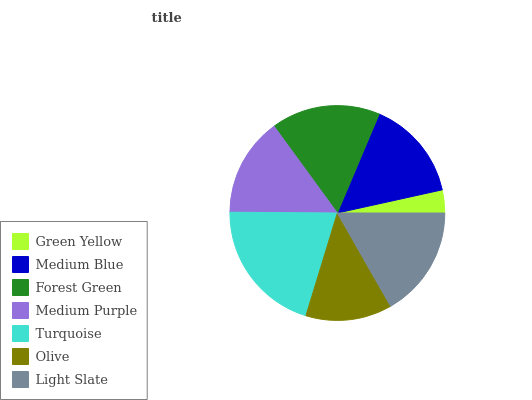Is Green Yellow the minimum?
Answer yes or no. Yes. Is Turquoise the maximum?
Answer yes or no. Yes. Is Medium Blue the minimum?
Answer yes or no. No. Is Medium Blue the maximum?
Answer yes or no. No. Is Medium Blue greater than Green Yellow?
Answer yes or no. Yes. Is Green Yellow less than Medium Blue?
Answer yes or no. Yes. Is Green Yellow greater than Medium Blue?
Answer yes or no. No. Is Medium Blue less than Green Yellow?
Answer yes or no. No. Is Medium Blue the high median?
Answer yes or no. Yes. Is Medium Blue the low median?
Answer yes or no. Yes. Is Light Slate the high median?
Answer yes or no. No. Is Olive the low median?
Answer yes or no. No. 